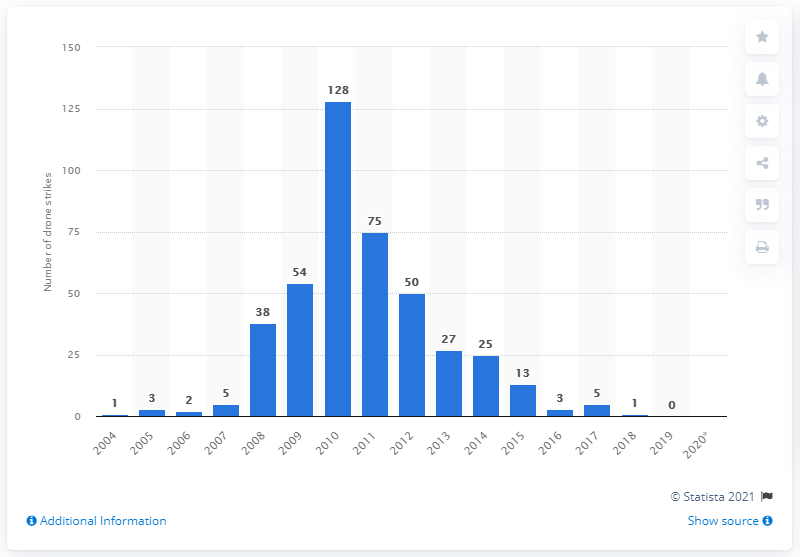Highlight a few significant elements in this photo. In the year 2019, there were no reported drone strikes in Pakistan. 